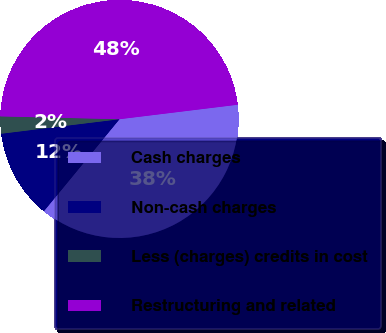Convert chart. <chart><loc_0><loc_0><loc_500><loc_500><pie_chart><fcel>Cash charges<fcel>Non-cash charges<fcel>Less (charges) credits in cost<fcel>Restructuring and related<nl><fcel>37.89%<fcel>12.11%<fcel>2.32%<fcel>47.68%<nl></chart> 